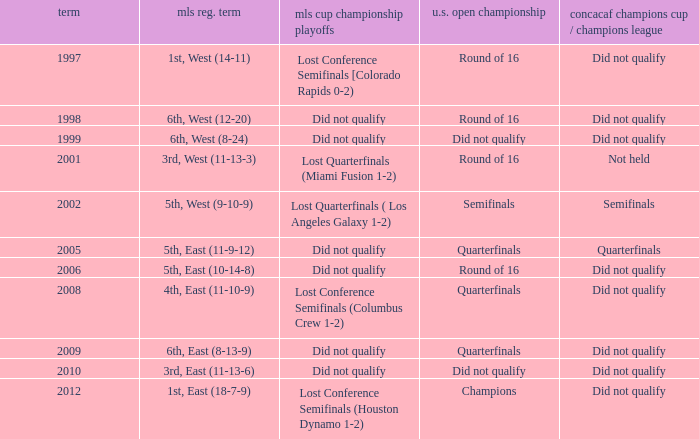What were the placements of the team in regular season when they reached quarterfinals in the U.S. Open Cup but did not qualify for the Concaf Champions Cup? 4th, East (11-10-9), 6th, East (8-13-9). 